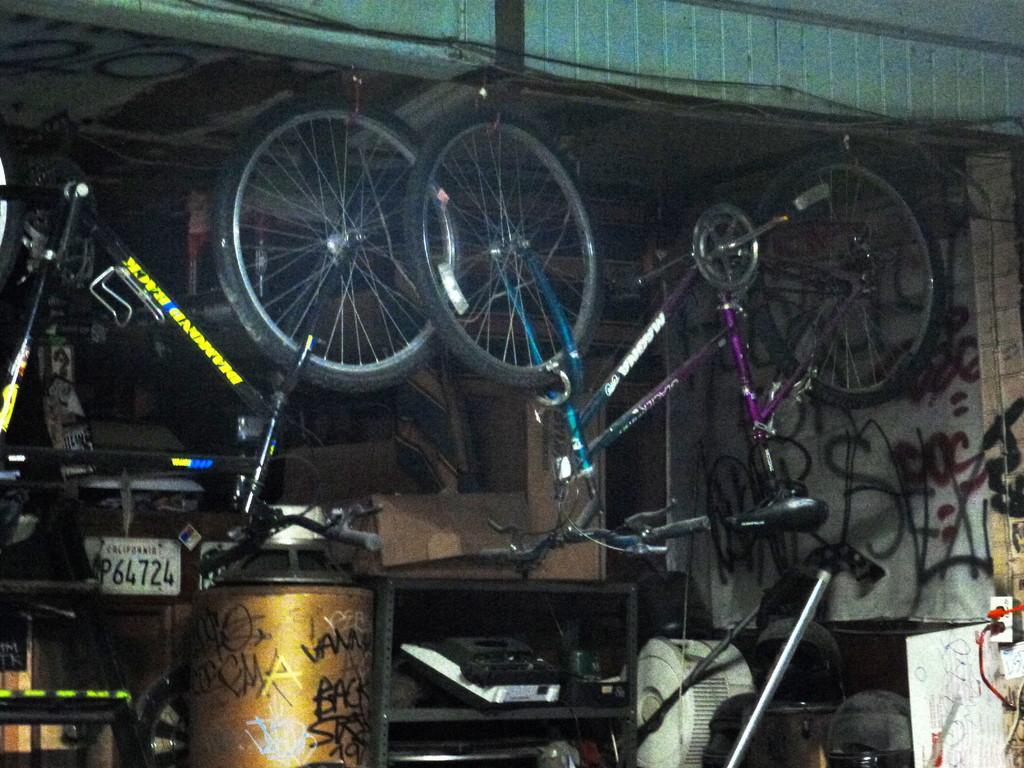Could you give a brief overview of what you see in this image? In this image I can see few bicycles. I can see few objects on the floor. In front I can see black color rack. 